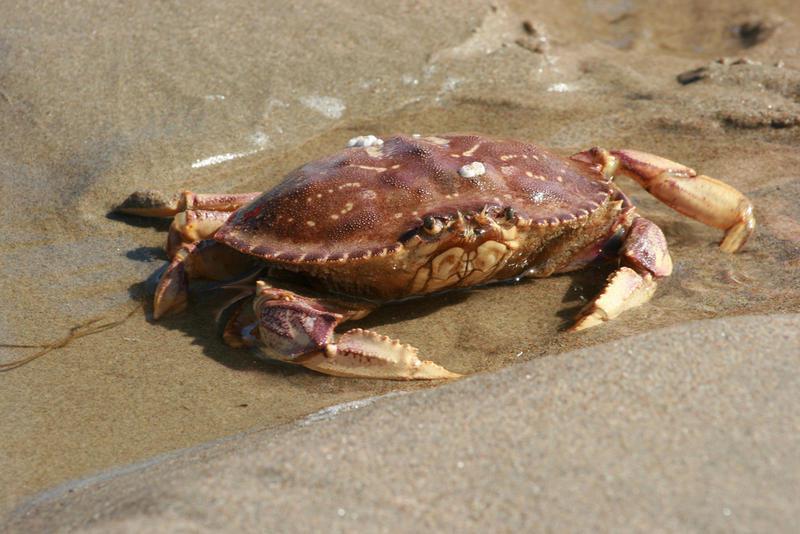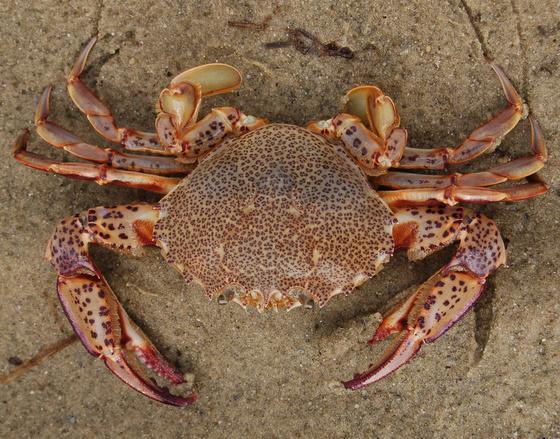The first image is the image on the left, the second image is the image on the right. Considering the images on both sides, is "Each image is a top-view of a crab with its face positioned at the bottom, and the crab on the left is more purplish and with black-tipped front claws, while the crab on the right is grayer." valid? Answer yes or no. No. 